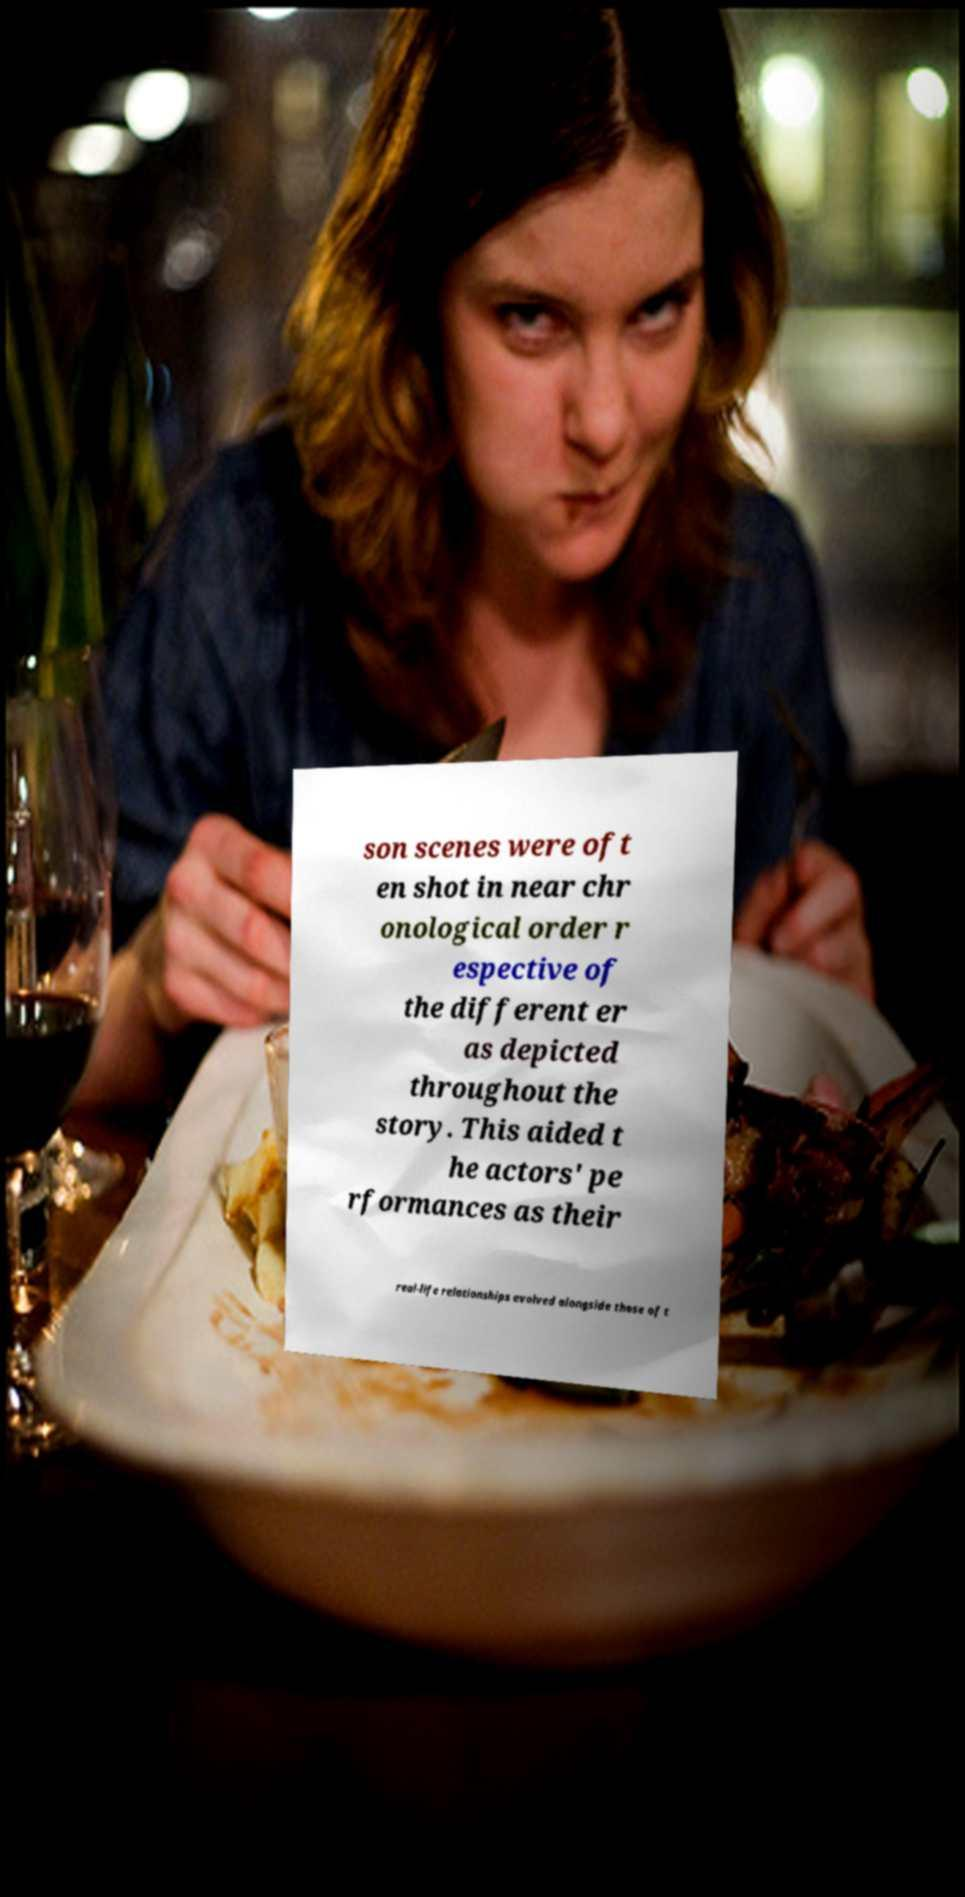Could you assist in decoding the text presented in this image and type it out clearly? son scenes were oft en shot in near chr onological order r espective of the different er as depicted throughout the story. This aided t he actors' pe rformances as their real-life relationships evolved alongside those of t 